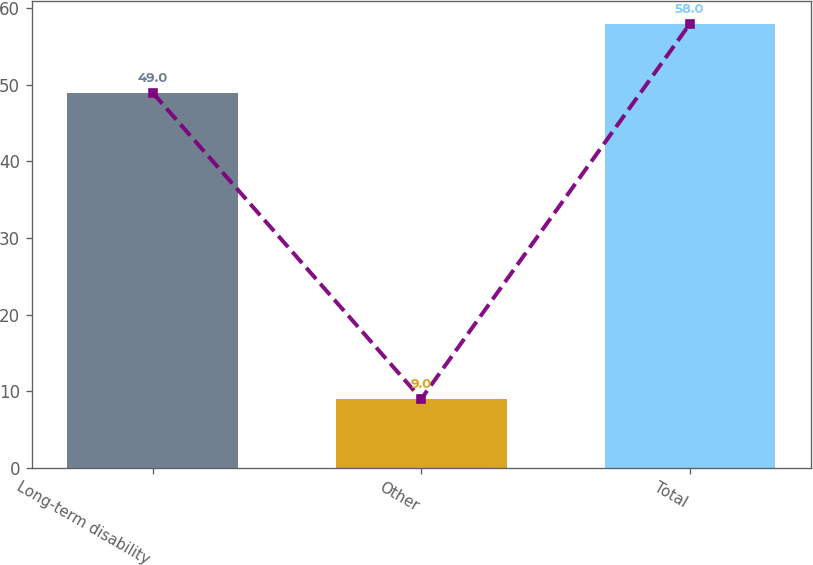Convert chart to OTSL. <chart><loc_0><loc_0><loc_500><loc_500><bar_chart><fcel>Long-term disability<fcel>Other<fcel>Total<nl><fcel>49<fcel>9<fcel>58<nl></chart> 